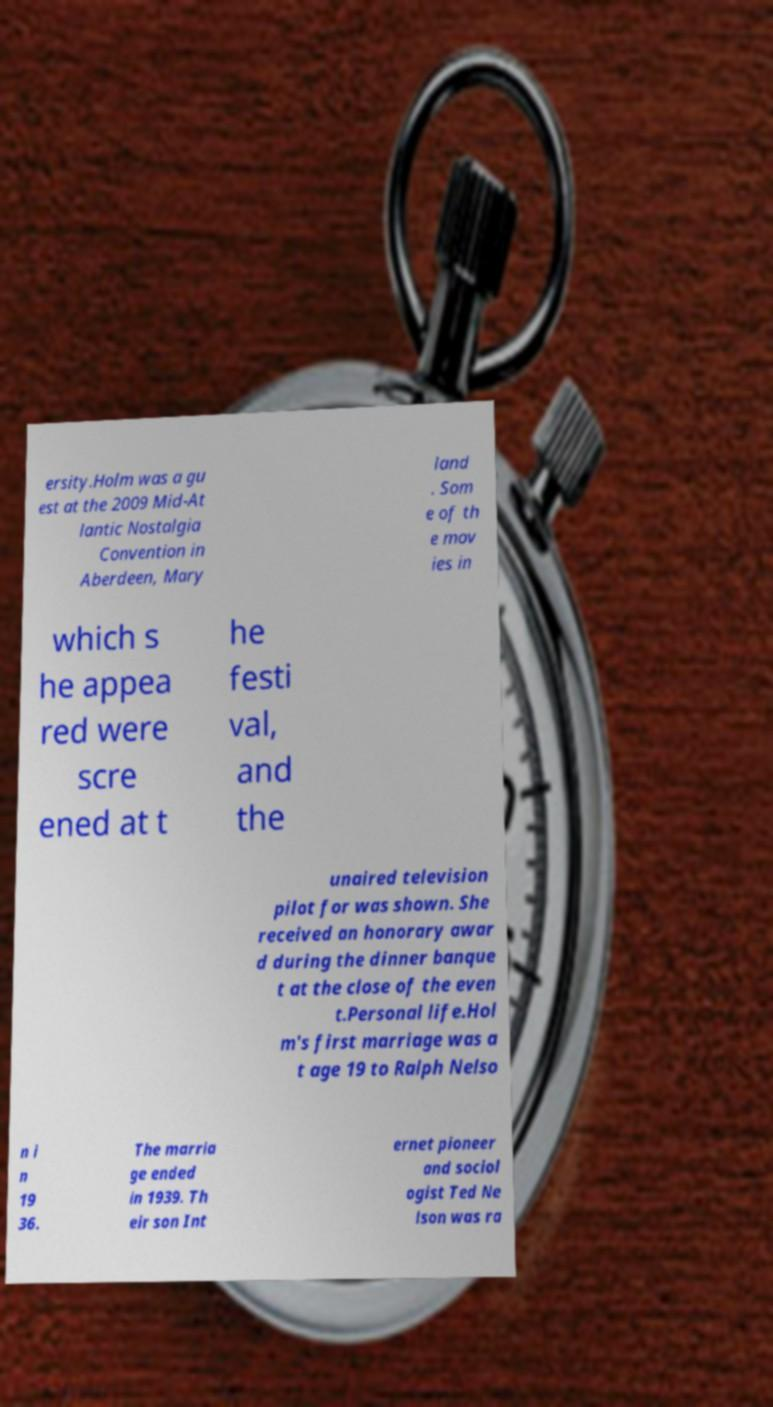Could you extract and type out the text from this image? ersity.Holm was a gu est at the 2009 Mid-At lantic Nostalgia Convention in Aberdeen, Mary land . Som e of th e mov ies in which s he appea red were scre ened at t he festi val, and the unaired television pilot for was shown. She received an honorary awar d during the dinner banque t at the close of the even t.Personal life.Hol m's first marriage was a t age 19 to Ralph Nelso n i n 19 36. The marria ge ended in 1939. Th eir son Int ernet pioneer and sociol ogist Ted Ne lson was ra 